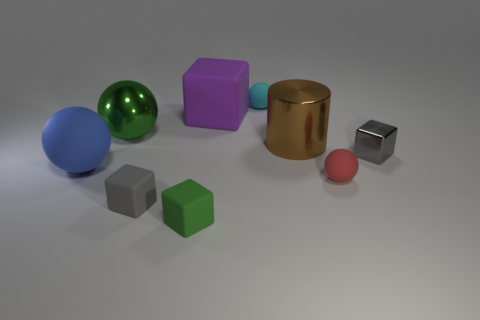Is there anything else that has the same color as the large cylinder?
Provide a short and direct response. No. How many small blocks are on the right side of the large purple matte block?
Ensure brevity in your answer.  1. Do the green thing behind the green matte block and the purple object have the same material?
Keep it short and to the point. No. How many tiny gray rubber objects have the same shape as the big brown thing?
Offer a terse response. 0. What number of large objects are either rubber cubes or purple objects?
Your response must be concise. 1. There is a tiny matte thing left of the tiny green rubber block; is it the same color as the shiny cube?
Give a very brief answer. Yes. Do the block that is right of the cyan matte thing and the tiny matte object to the left of the green matte cube have the same color?
Your answer should be compact. Yes. Are there any tiny purple cylinders made of the same material as the green ball?
Keep it short and to the point. No. How many gray objects are big metal balls or tiny blocks?
Give a very brief answer. 2. Is the number of red spheres that are on the right side of the brown metallic cylinder greater than the number of tiny purple rubber things?
Offer a terse response. Yes. 